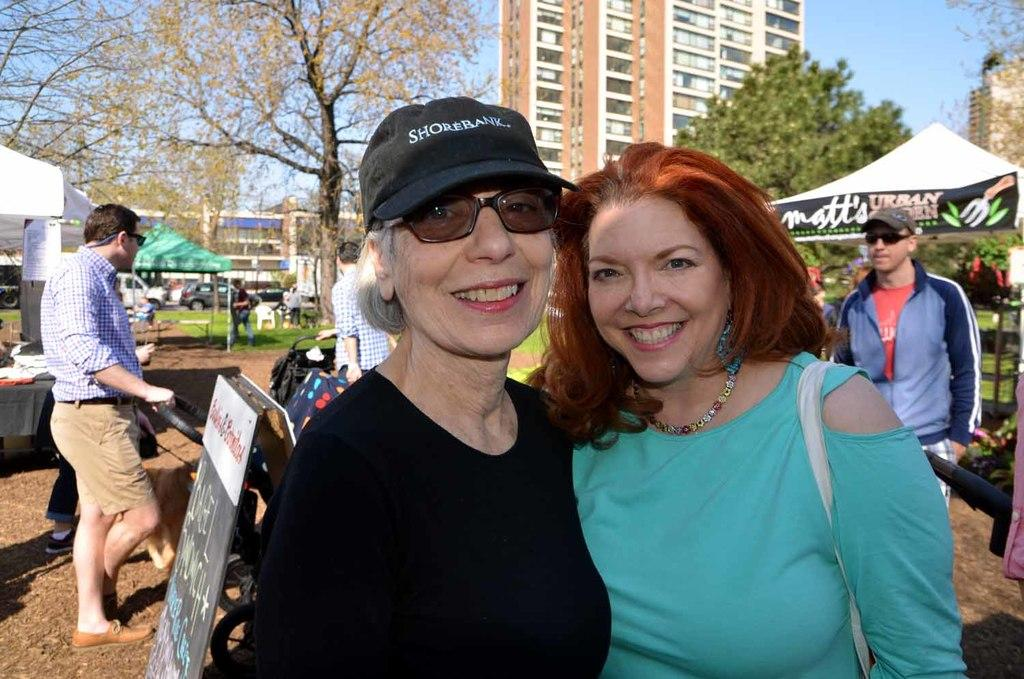What are the two main subjects in the image? There are two men posing for a photograph in the image. What can be seen in the background of the image? In the background, there are people walking, stalls, trees, a building, and the sky. What might be happening in the area where the image was taken? The presence of stalls and people walking suggests that there may be some sort of event or gathering taking place. What type of office can be seen in the image? There is no office present in the image; it features two men posing for a photograph and a background with people walking, stalls, trees, a building, and the sky. 